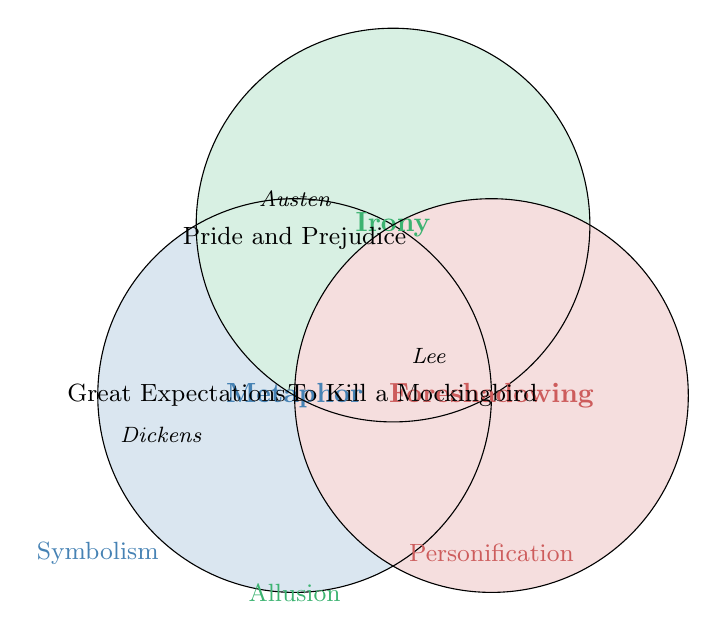What literary device is represented by the blue circle? Identify the color-coded circle and match it with the label within the circle.
Answer: Metaphor Which novels are associated with the red circle's literary device? Read the novels listed within or near the red circle.
Answer: To Kill a Mockingbird;The Catcher in the Rye Who are the authors linked to the literary device indicated by the green circle? Identify the authors listed near or within the green circle.
Answer: Jane Austen;George Orwell Which novel appears in conjunction with 'Metaphor' and is written by Dickens? Look for novels and authors associated with the blue circle and find the overlap.
Answer: Great Expectations How many novels are represented in the diagram? Count the novels mentioned in all circles of the Venn Diagram.
Answer: Six Which literary device is not represented by any circle in the Venn Diagram? Identify the devices listed outside the circles.
Answer: Symbolism;Allusion;Personification What is the common novel in the overlapping areas if any? Check the central region where all the circles might overlap.
Answer: None Which circle contains the novel '1984'? Identify the circle with the corresponding novel near it.
Answer: Irony What are the other devices mentioned outside the circles but within the diagram? List the literary devices that are positioned outside the three circles in the diagram.
Answer: Symbolism;Allusion;Personification How many different authors are noted in the diagram? Count the unique authors listed in or around the circles.
Answer: Six 